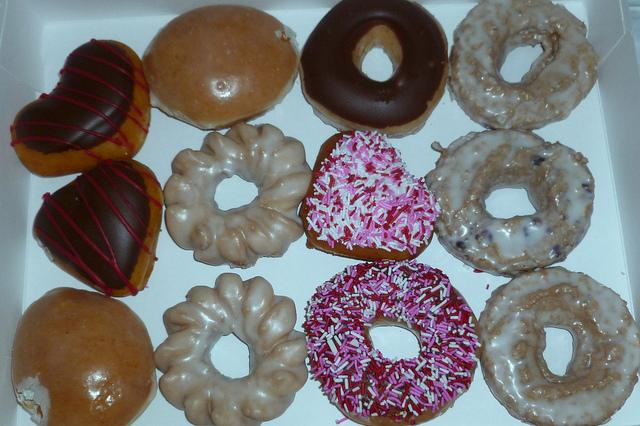How many of the dozen donuts could be cream-filled?

Choices:
A) three
B) seven
C) five
D) two five 